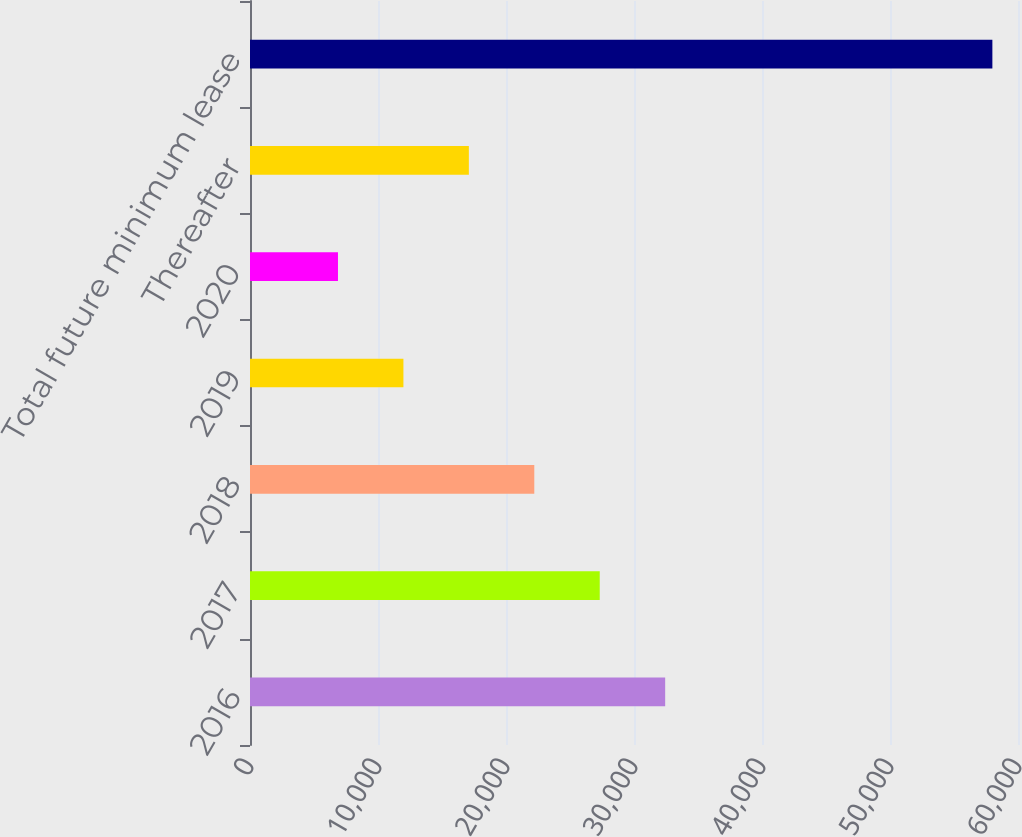Convert chart. <chart><loc_0><loc_0><loc_500><loc_500><bar_chart><fcel>2016<fcel>2017<fcel>2018<fcel>2019<fcel>2020<fcel>Thereafter<fcel>Total future minimum lease<nl><fcel>32435.5<fcel>27323<fcel>22210.5<fcel>11985.5<fcel>6873<fcel>17098<fcel>57998<nl></chart> 